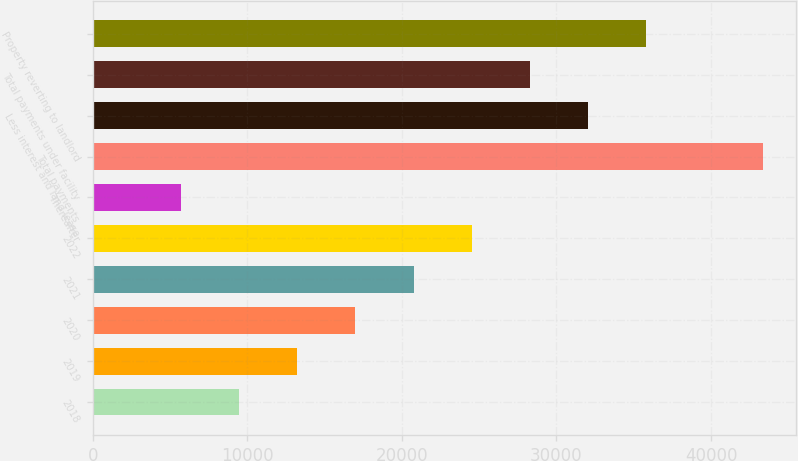Convert chart to OTSL. <chart><loc_0><loc_0><loc_500><loc_500><bar_chart><fcel>2018<fcel>2019<fcel>2020<fcel>2021<fcel>2022<fcel>Thereafter<fcel>Total payments<fcel>Less interest and land lease<fcel>Total payments under facility<fcel>Property reverting to landlord<nl><fcel>9453.6<fcel>13220.9<fcel>16988.2<fcel>20755.5<fcel>24522.8<fcel>5686.3<fcel>43359.3<fcel>32057.4<fcel>28290.1<fcel>35824.7<nl></chart> 